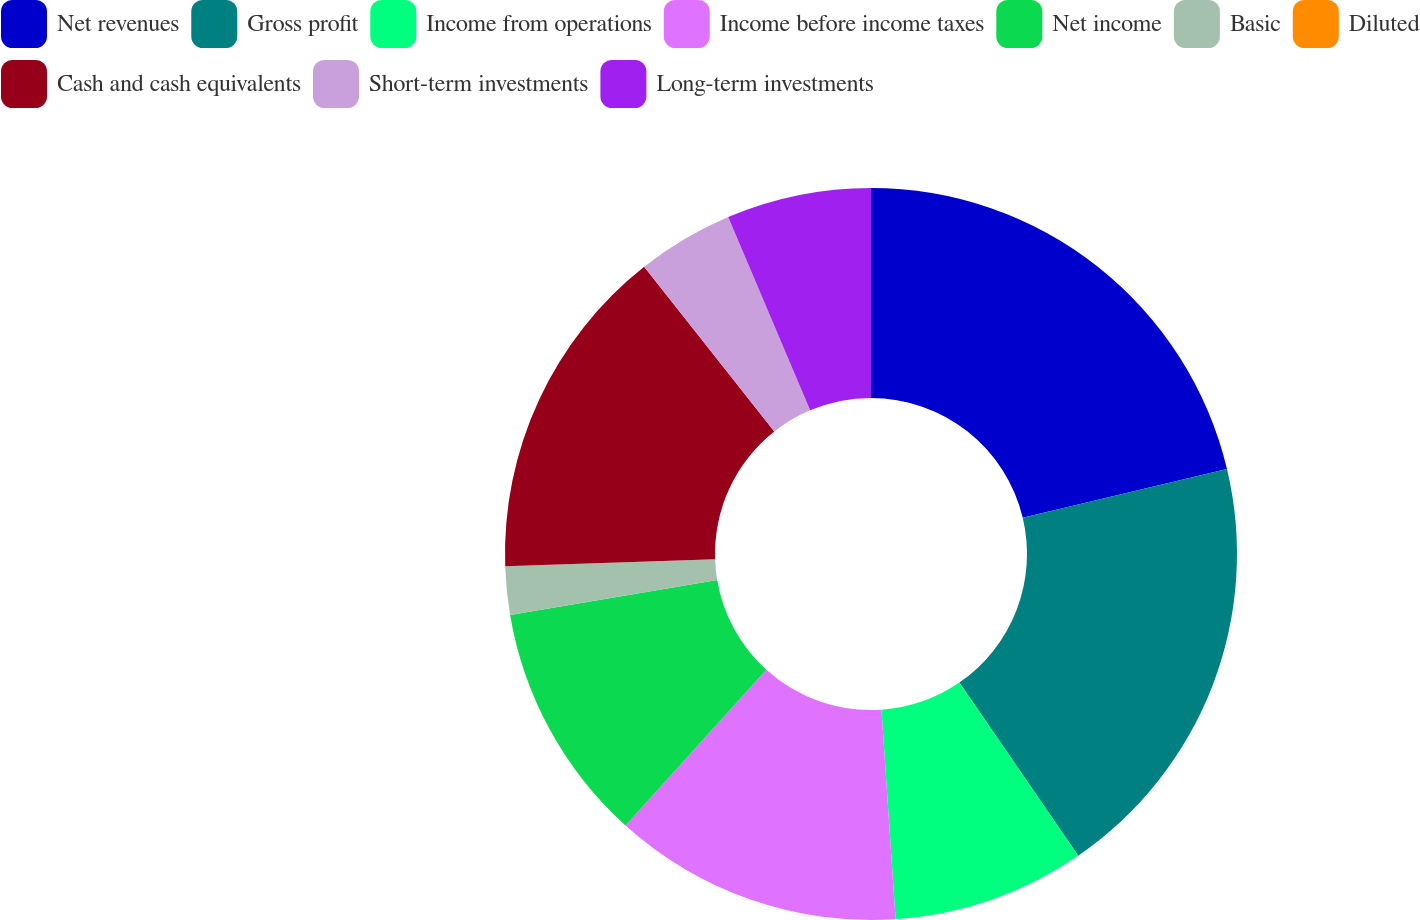Convert chart to OTSL. <chart><loc_0><loc_0><loc_500><loc_500><pie_chart><fcel>Net revenues<fcel>Gross profit<fcel>Income from operations<fcel>Income before income taxes<fcel>Net income<fcel>Basic<fcel>Diluted<fcel>Cash and cash equivalents<fcel>Short-term investments<fcel>Long-term investments<nl><fcel>21.27%<fcel>19.15%<fcel>8.51%<fcel>12.77%<fcel>10.64%<fcel>2.13%<fcel>0.0%<fcel>14.89%<fcel>4.26%<fcel>6.38%<nl></chart> 